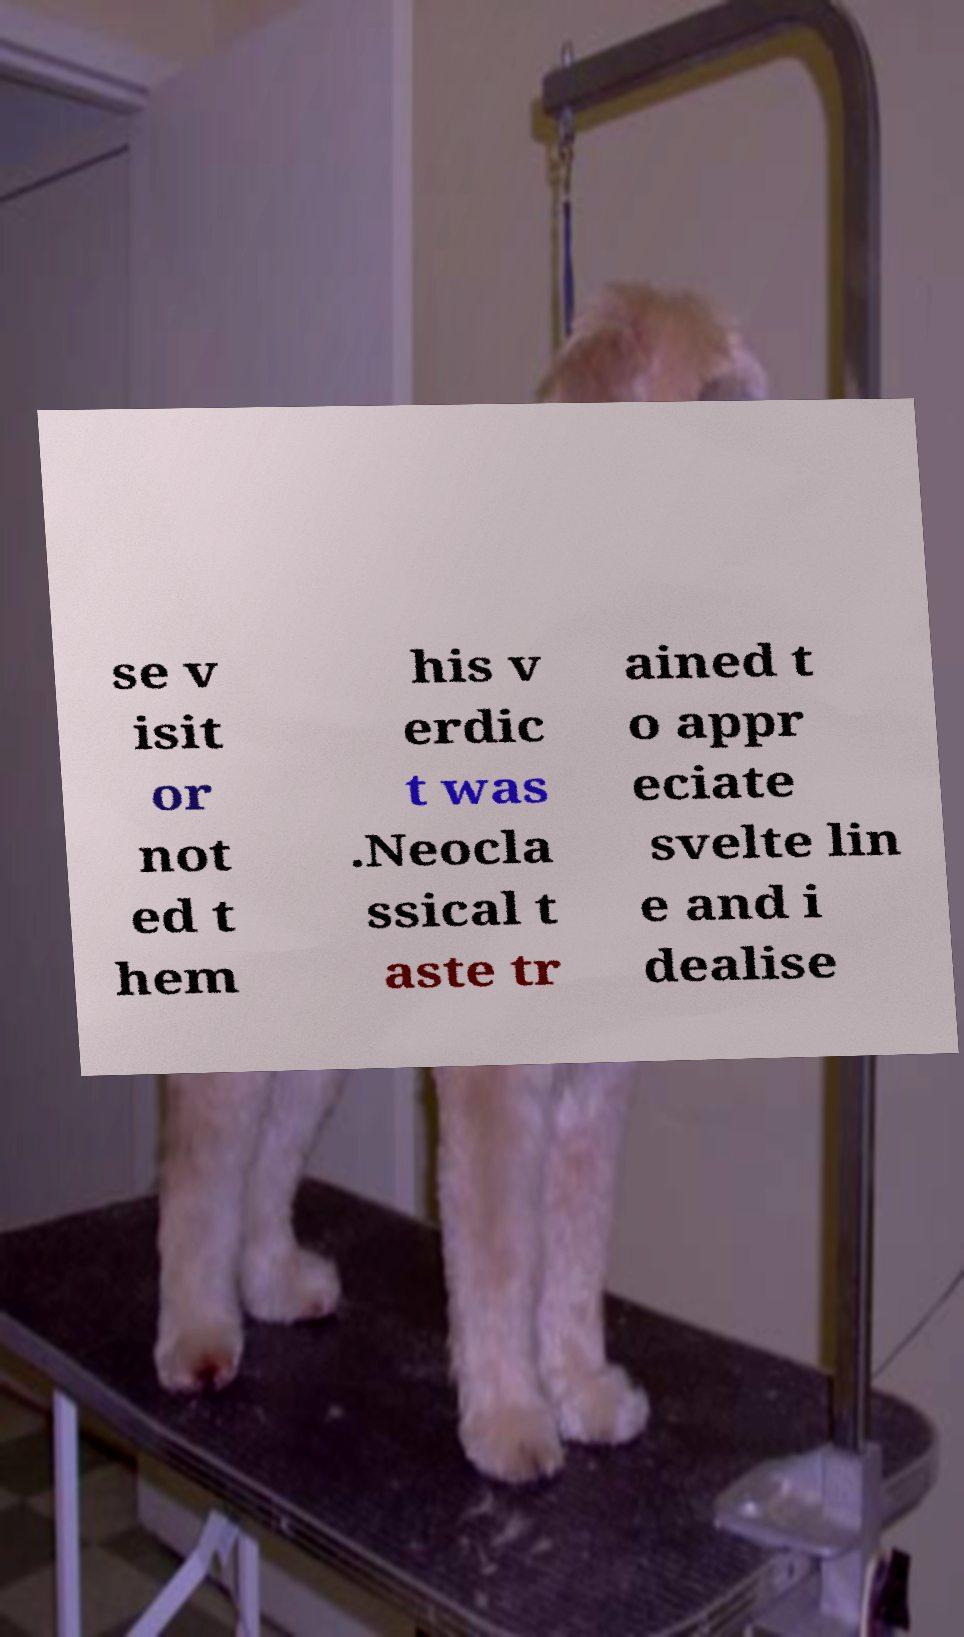For documentation purposes, I need the text within this image transcribed. Could you provide that? se v isit or not ed t hem his v erdic t was .Neocla ssical t aste tr ained t o appr eciate svelte lin e and i dealise 